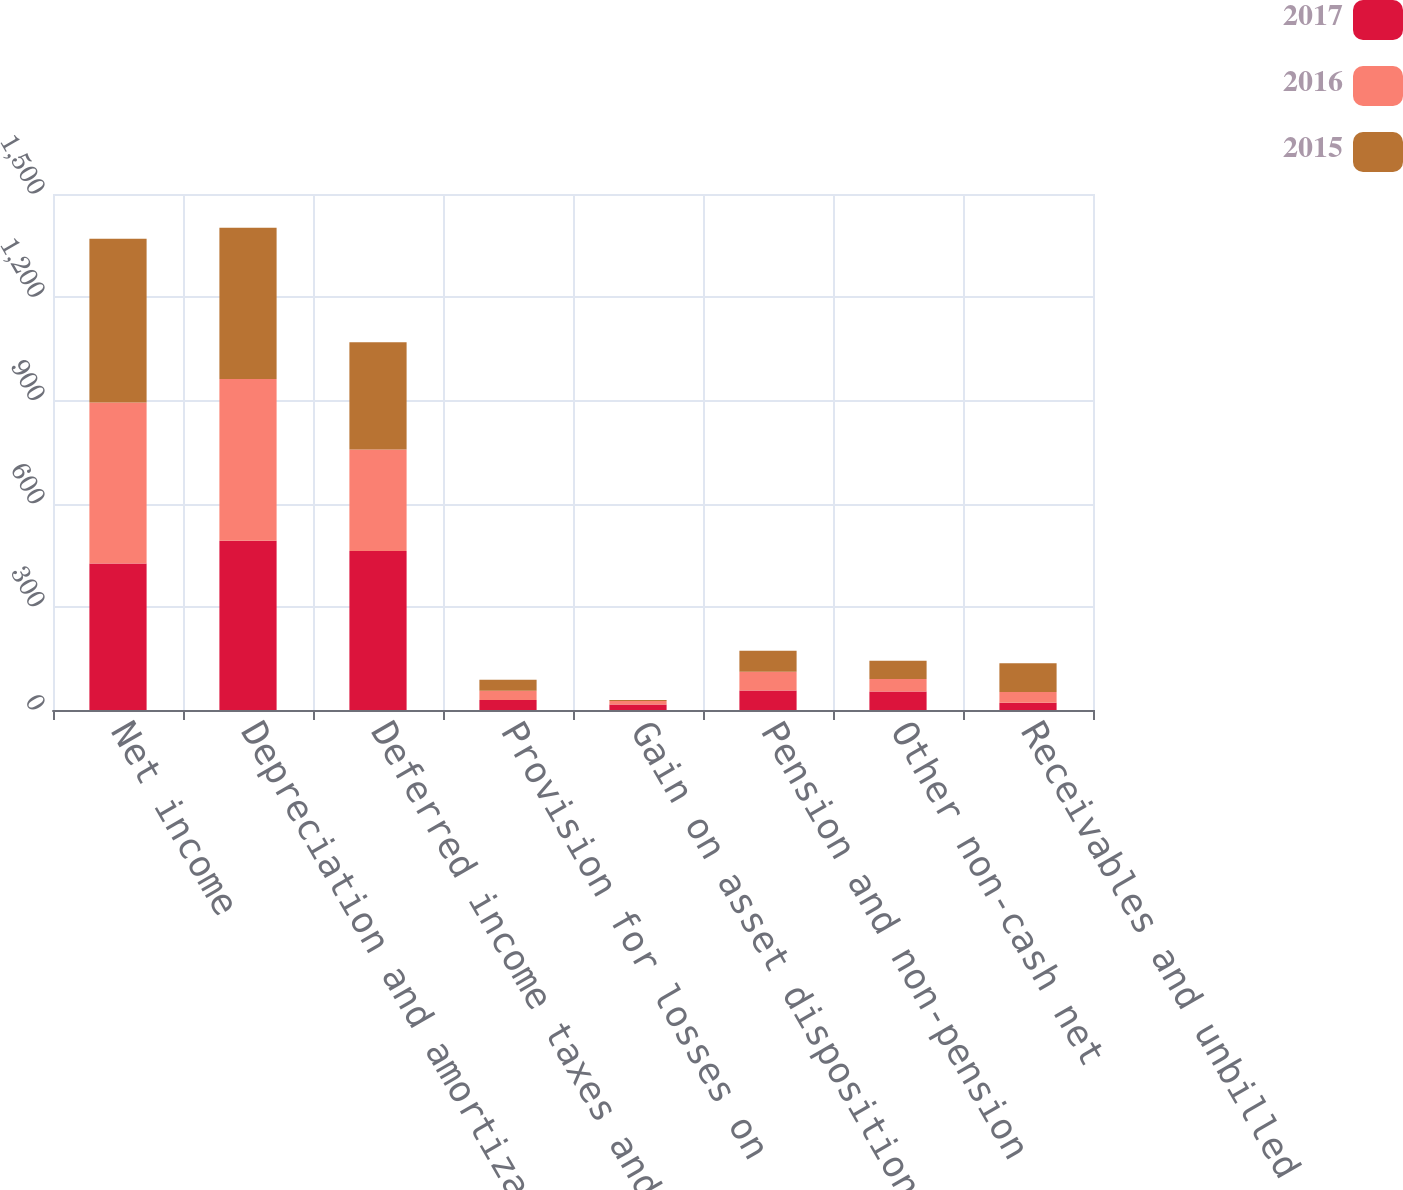Convert chart to OTSL. <chart><loc_0><loc_0><loc_500><loc_500><stacked_bar_chart><ecel><fcel>Net income<fcel>Depreciation and amortization<fcel>Deferred income taxes and<fcel>Provision for losses on<fcel>Gain on asset dispositions and<fcel>Pension and non-pension<fcel>Other non-cash net<fcel>Receivables and unbilled<nl><fcel>2017<fcel>426<fcel>492<fcel>462<fcel>29<fcel>16<fcel>57<fcel>54<fcel>21<nl><fcel>2016<fcel>468<fcel>470<fcel>295<fcel>27<fcel>10<fcel>54<fcel>36<fcel>31<nl><fcel>2015<fcel>476<fcel>440<fcel>312<fcel>32<fcel>3<fcel>61<fcel>53<fcel>84<nl></chart> 